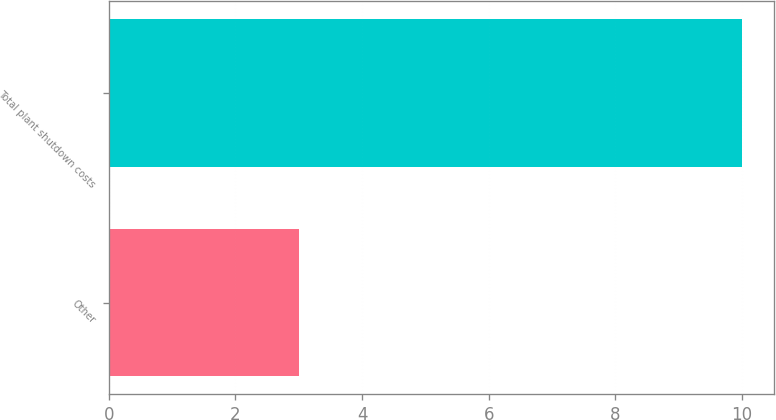<chart> <loc_0><loc_0><loc_500><loc_500><bar_chart><fcel>Other<fcel>Total plant shutdown costs<nl><fcel>3<fcel>10<nl></chart> 